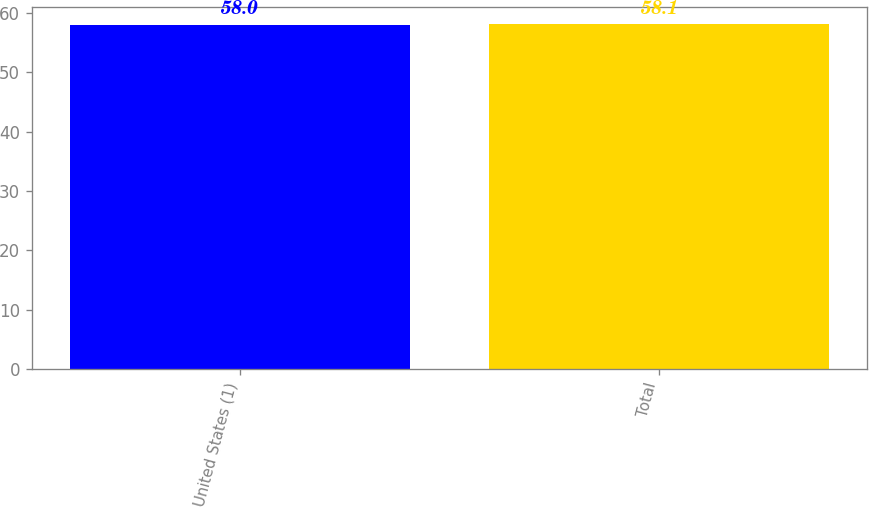<chart> <loc_0><loc_0><loc_500><loc_500><bar_chart><fcel>United States (1)<fcel>Total<nl><fcel>58<fcel>58.1<nl></chart> 